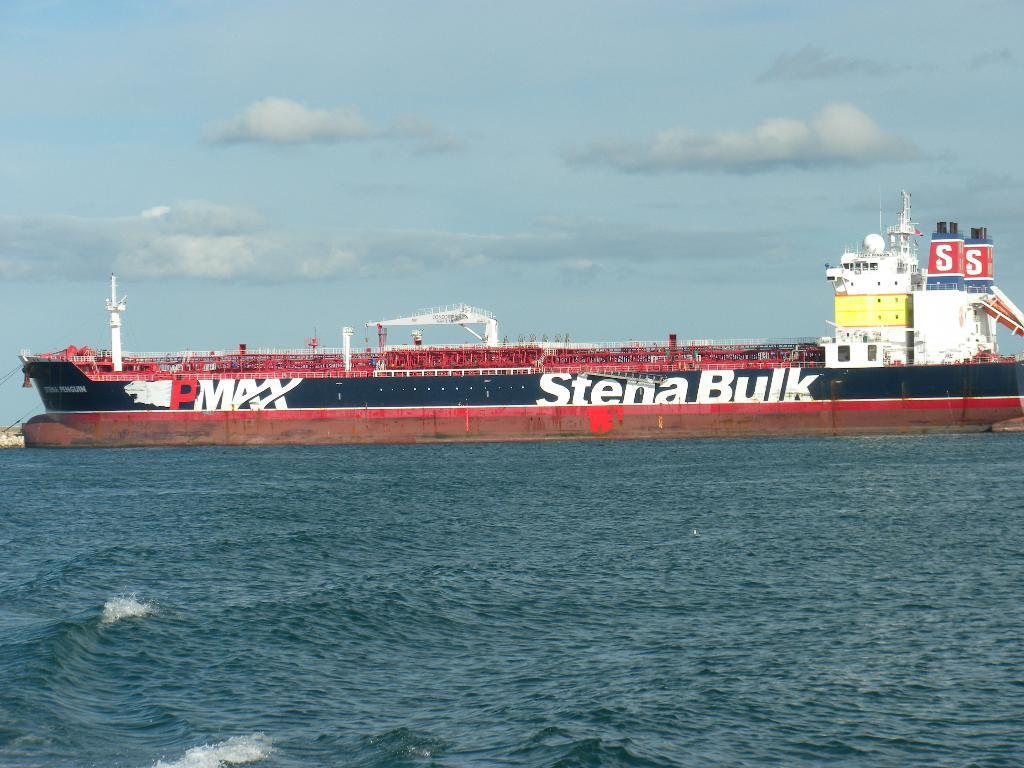In one or two sentences, can you explain what this image depicts? In this image we can see a ship on the ocean, also we can see the cloudy sky. 